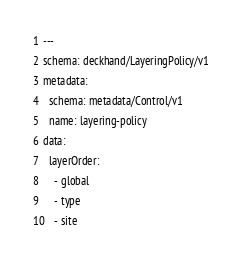Convert code to text. <code><loc_0><loc_0><loc_500><loc_500><_YAML_>---
schema: deckhand/LayeringPolicy/v1
metadata:
  schema: metadata/Control/v1
  name: layering-policy
data:
  layerOrder:
    - global
    - type
    - site
</code> 